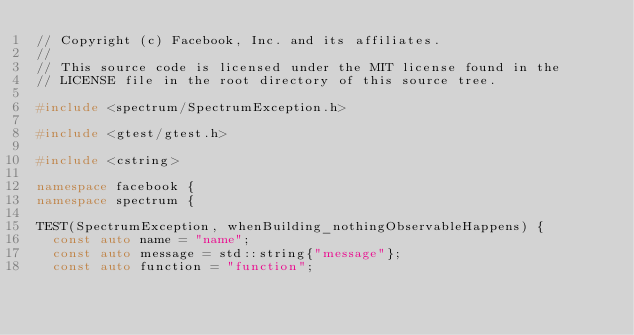Convert code to text. <code><loc_0><loc_0><loc_500><loc_500><_C++_>// Copyright (c) Facebook, Inc. and its affiliates.
//
// This source code is licensed under the MIT license found in the
// LICENSE file in the root directory of this source tree.

#include <spectrum/SpectrumException.h>

#include <gtest/gtest.h>

#include <cstring>

namespace facebook {
namespace spectrum {

TEST(SpectrumException, whenBuilding_nothingObservableHappens) {
  const auto name = "name";
  const auto message = std::string{"message"};
  const auto function = "function";</code> 